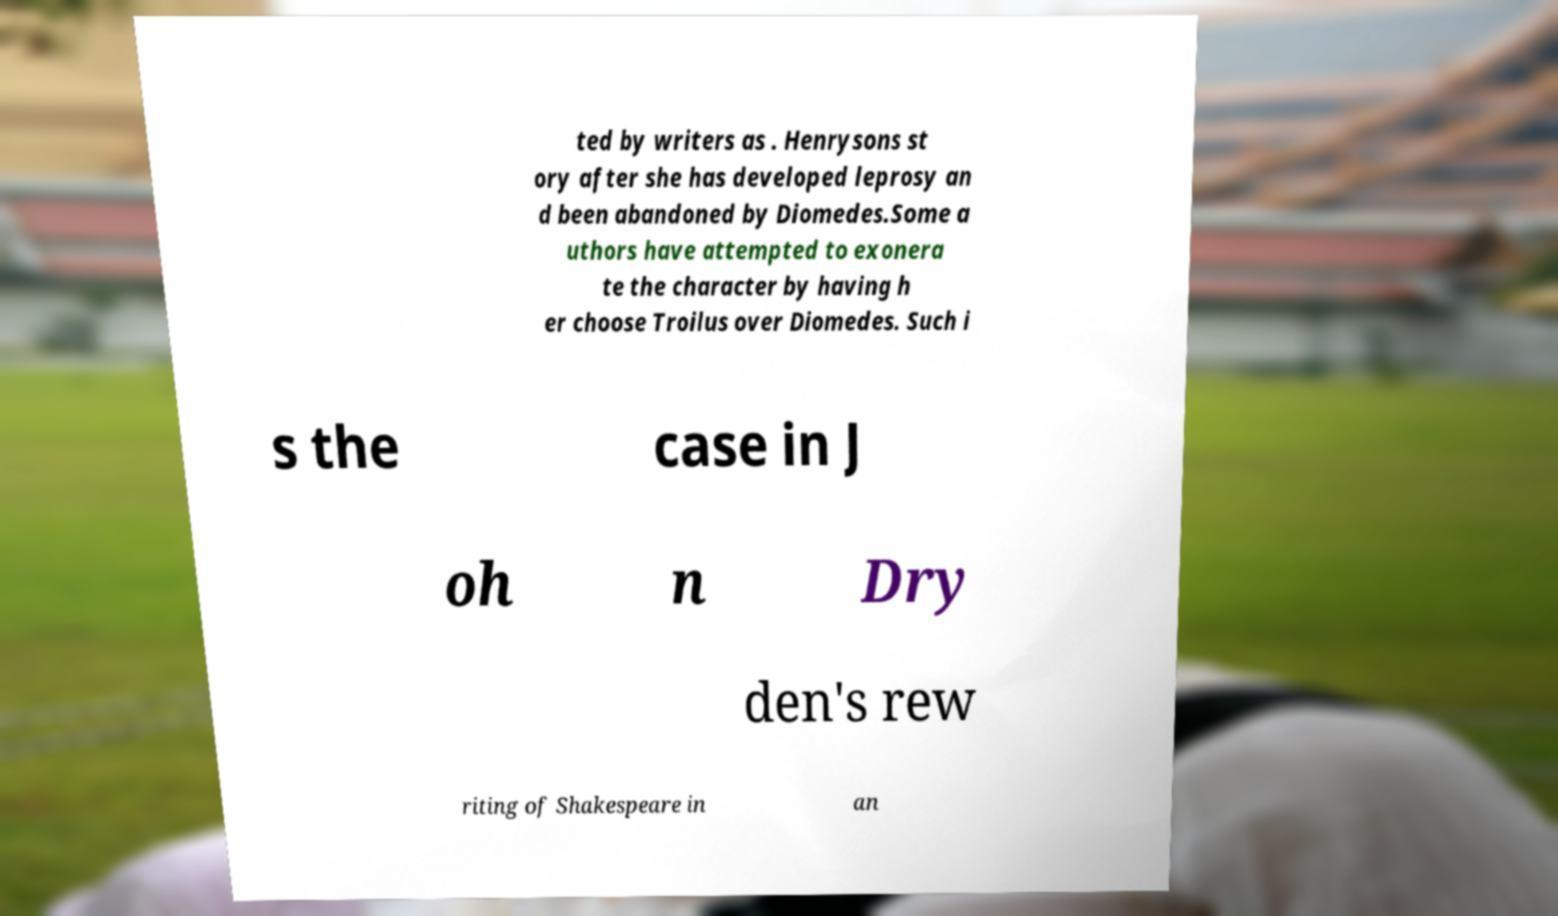What messages or text are displayed in this image? I need them in a readable, typed format. ted by writers as . Henrysons st ory after she has developed leprosy an d been abandoned by Diomedes.Some a uthors have attempted to exonera te the character by having h er choose Troilus over Diomedes. Such i s the case in J oh n Dry den's rew riting of Shakespeare in an 